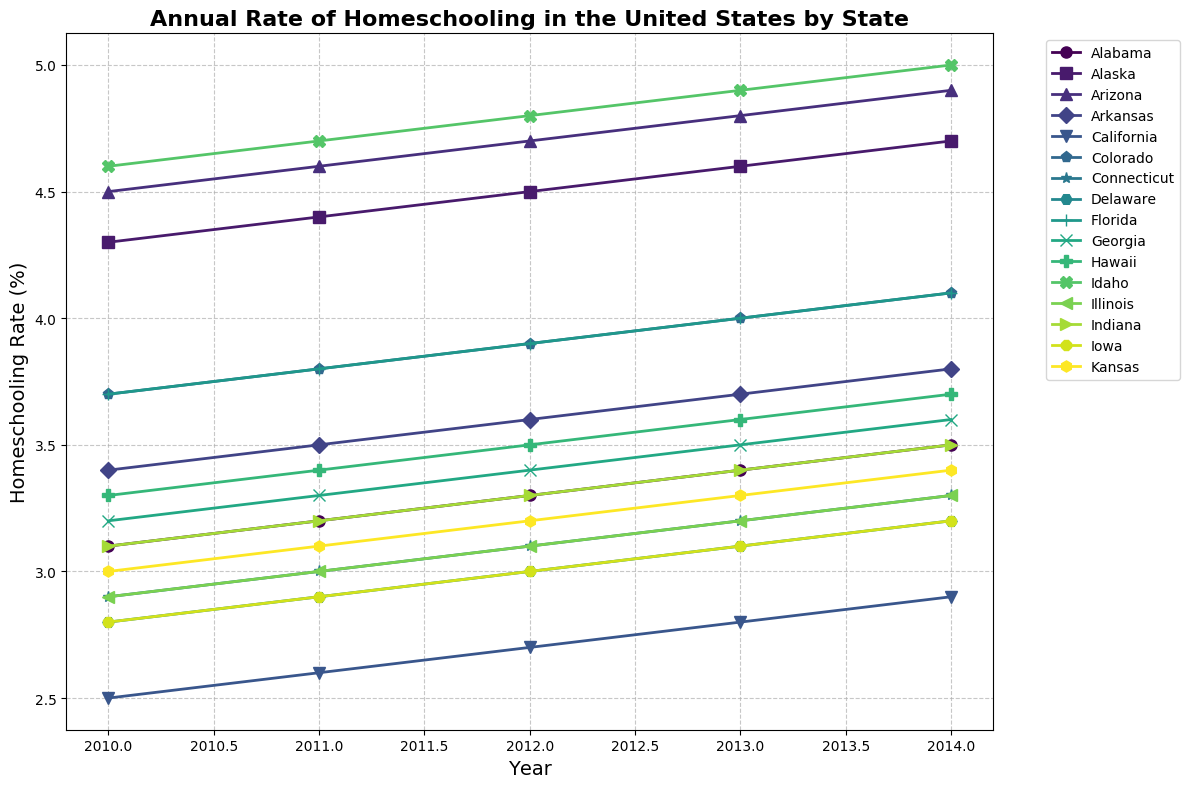What's the state with the highest homeschooling rate in 2010? Look at the lines for the year 2010 and identify the state with the highest point on the y-axis. Idaho has the highest homeschooling rate with 4.6%.
Answer: Idaho How does the homeschooling rate in California change from 2010 to 2014? Trace the line representing California from 2010 to 2014. The rate increases from 2.5% in 2010 to 2.9% in 2014.
Answer: Increased Between which two consecutive years did Idaho see the greatest increase in homeschooling rate? Examine the rate for Idaho year by year and note the changes. The greatest increase is from 2013 to 2014, moving from 4.9% to 5.0%.
Answer: 2013 to 2014 Which state had the smallest change in homeschooling rate between 2010 and 2014? Calculate the differences in homeschooling rates for each state over the period and compare. California's rate changed by only 0.4%, which is the smallest change.
Answer: California What is the average homeschooling rate for Georgia from 2010 to 2014? Add Georgia's rates for each year from 2010 to 2014 (3.2%, 3.3%, 3.4%, 3.5%, 3.6%) and divide by the number of years (5). (3.2+3.3+3.4+3.5+3.6)/5 = 3.4%.
Answer: 3.4% Which state shows a consistent increase in homeschooling rate every year from 2010 to 2014? Draw lines for each state and observe the trends. Idaho consistently increases every year from 4.6% in 2010 to 5.0% in 2014.
Answer: Idaho Is the homeschooling rate in Colorado higher or lower than the average rate of all states in 2011? Add up the rates of all states for 2011 and divide by the number of states to find the average rate. The average rate is 3.43%, while Colorado has 3.8%. Therefore, Colorado is higher.
Answer: Higher What is the total increase in homeschooling rate for Alabama from 2010 to 2014? Subtract Alabama’s 2010 rate (3.1%) from its 2014 rate (3.5%). The increase is 3.5% - 3.1% = 0.4%.
Answer: 0.4% Which states had a homeschooling rate greater than 4% in both 2010 and 2014? Find the states with rates above 4% for both years. Only Alaska, Arizona, and Idaho fit this criterion.
Answer: Alaska, Arizona, Idaho Which year had the highest average homeschooling rate across all states? Calculate the average rate for each year and compare. 2014 had the highest average rate with 3.585%.
Answer: 2014 